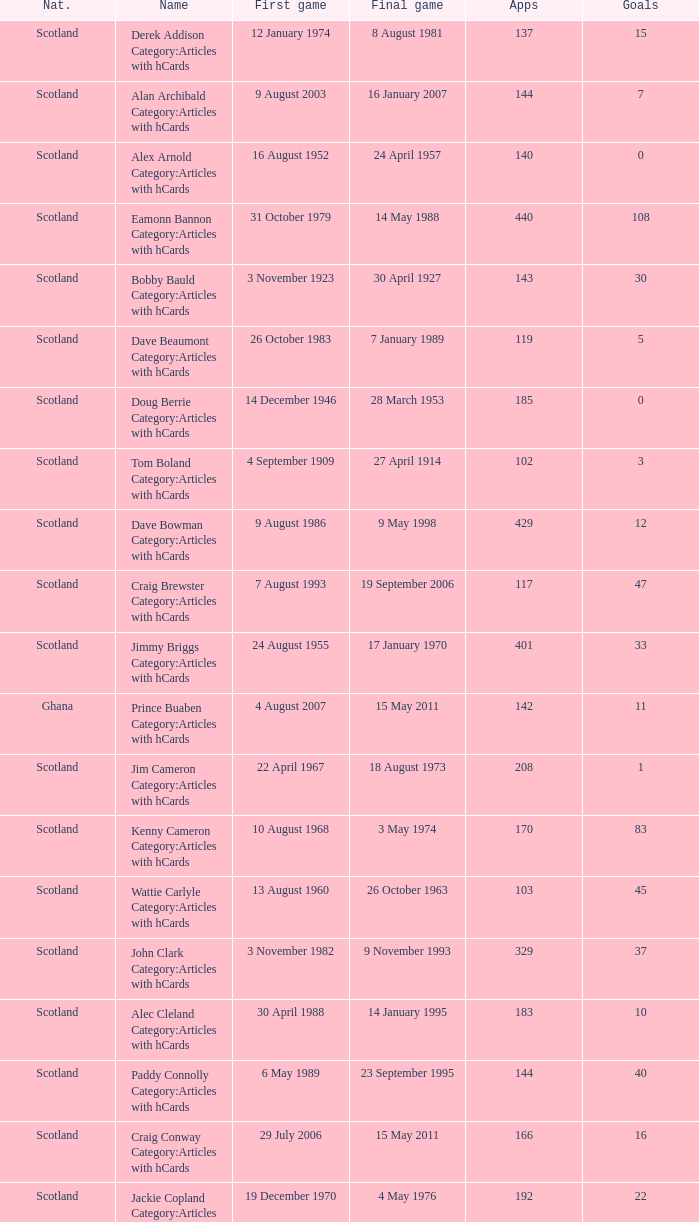What label has 118 as the applications? Ron Yeats Category:Articles with hCards. 